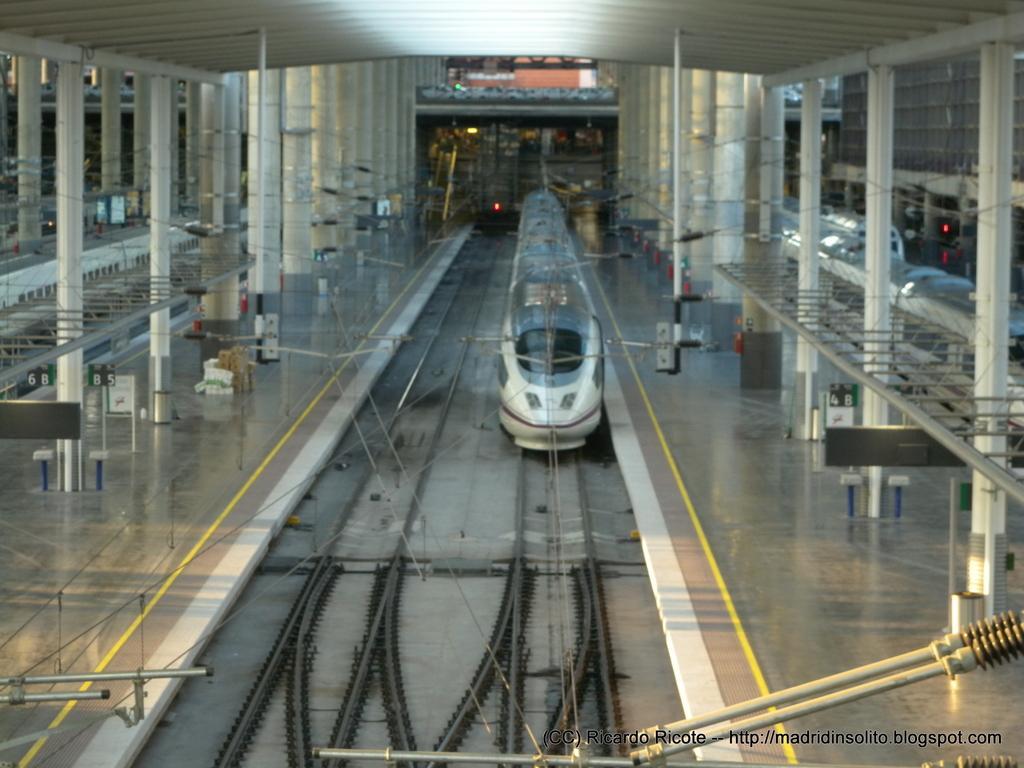In one or two sentences, can you explain what this image depicts? In this picture there is a train on the railway track. There is a building and there are boards hanging to the rods. There are objects on the floor. At the top there is a roof. At the bottom there are railway tracks and there is a floor. At the bottom right there is text. 